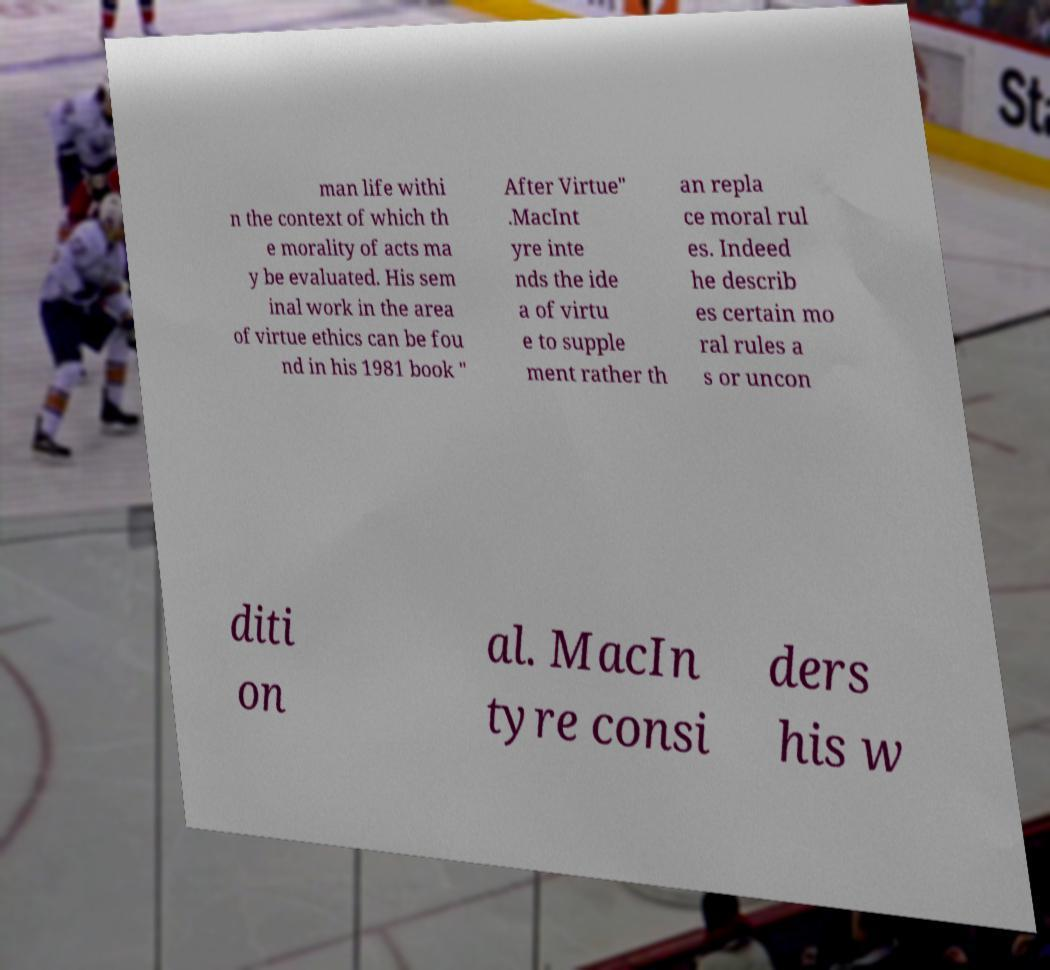Please read and relay the text visible in this image. What does it say? man life withi n the context of which th e morality of acts ma y be evaluated. His sem inal work in the area of virtue ethics can be fou nd in his 1981 book " After Virtue" .MacInt yre inte nds the ide a of virtu e to supple ment rather th an repla ce moral rul es. Indeed he describ es certain mo ral rules a s or uncon diti on al. MacIn tyre consi ders his w 